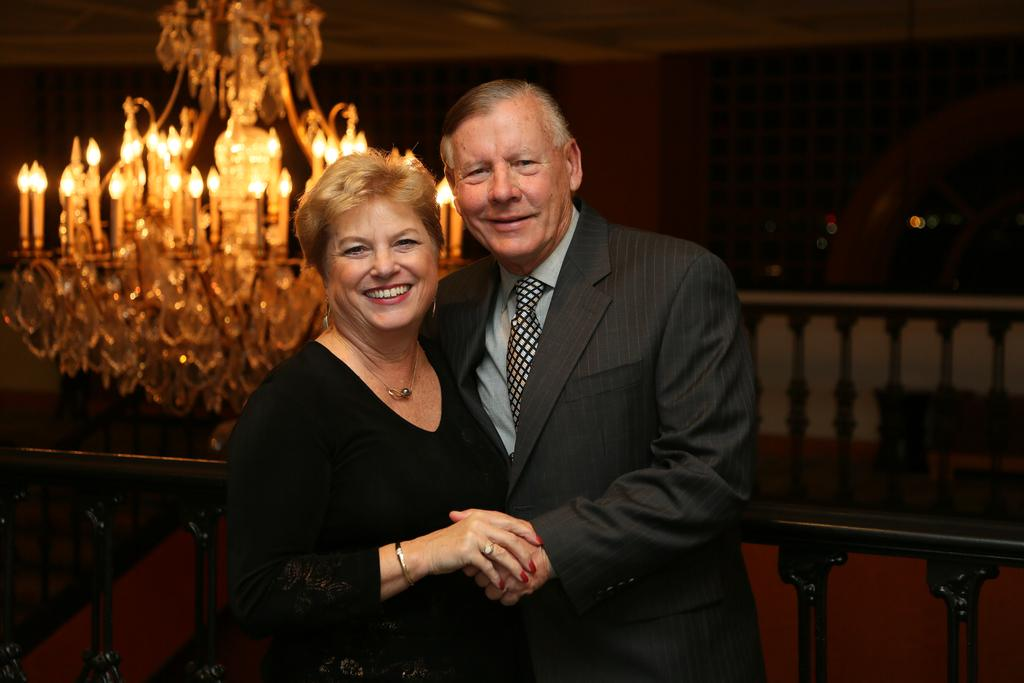Who is present in the image? There is a man and a woman in the image. What are the expressions of the man and woman in the image? Both the man and woman are smiling in the image. What type of lighting is visible in the image? There is a chandelier light visible in the image. Are the man and woman touching a basin in the image? There is no basin present in the image, so it cannot be determined if the man and woman are touching one. 